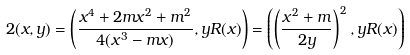Convert formula to latex. <formula><loc_0><loc_0><loc_500><loc_500>2 ( x , y ) = \left ( \frac { x ^ { 4 } + 2 m x ^ { 2 } + m ^ { 2 } } { 4 ( x ^ { 3 } - m x ) } , y R ( x ) \right ) = \left ( \left ( \frac { x ^ { 2 } + m } { 2 y } \right ) ^ { 2 } , y R ( x ) \right )</formula> 